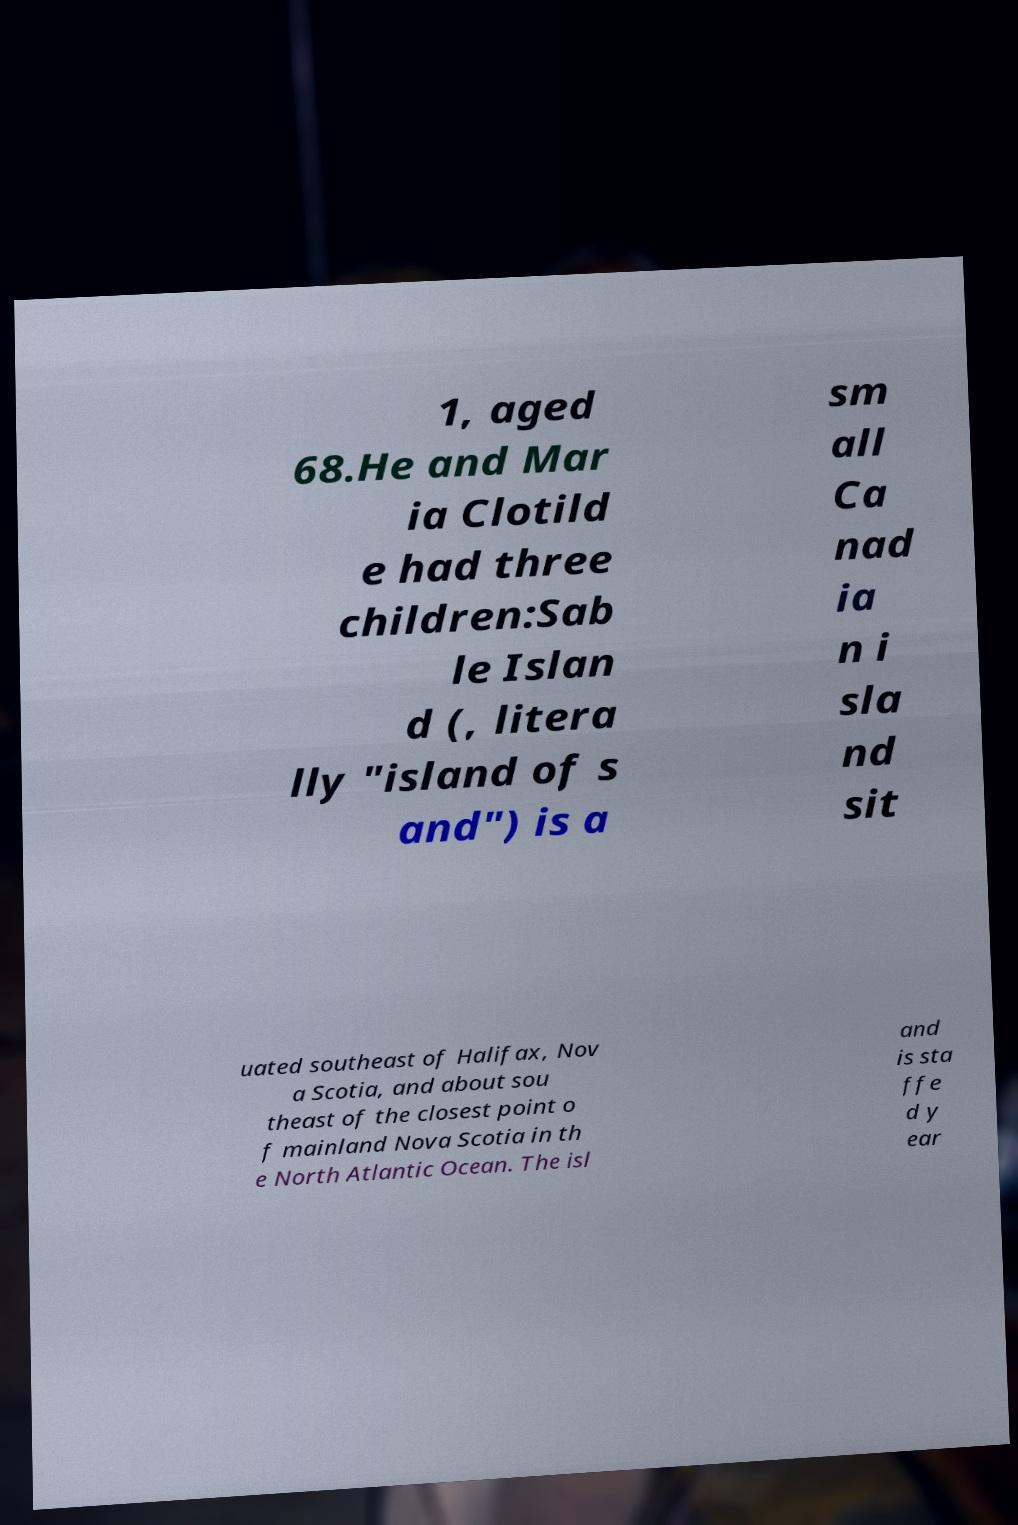What messages or text are displayed in this image? I need them in a readable, typed format. 1, aged 68.He and Mar ia Clotild e had three children:Sab le Islan d (, litera lly "island of s and") is a sm all Ca nad ia n i sla nd sit uated southeast of Halifax, Nov a Scotia, and about sou theast of the closest point o f mainland Nova Scotia in th e North Atlantic Ocean. The isl and is sta ffe d y ear 